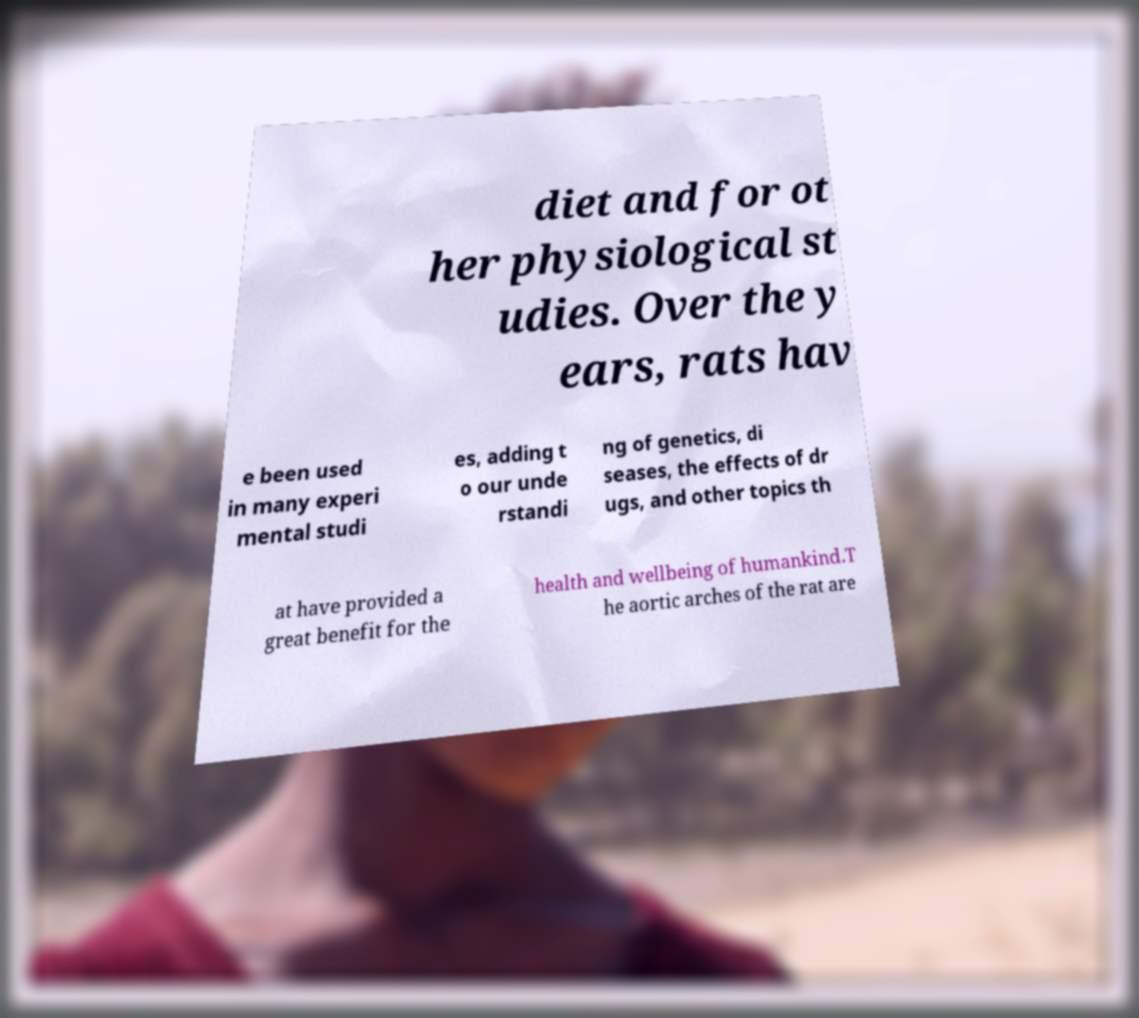Can you accurately transcribe the text from the provided image for me? diet and for ot her physiological st udies. Over the y ears, rats hav e been used in many experi mental studi es, adding t o our unde rstandi ng of genetics, di seases, the effects of dr ugs, and other topics th at have provided a great benefit for the health and wellbeing of humankind.T he aortic arches of the rat are 